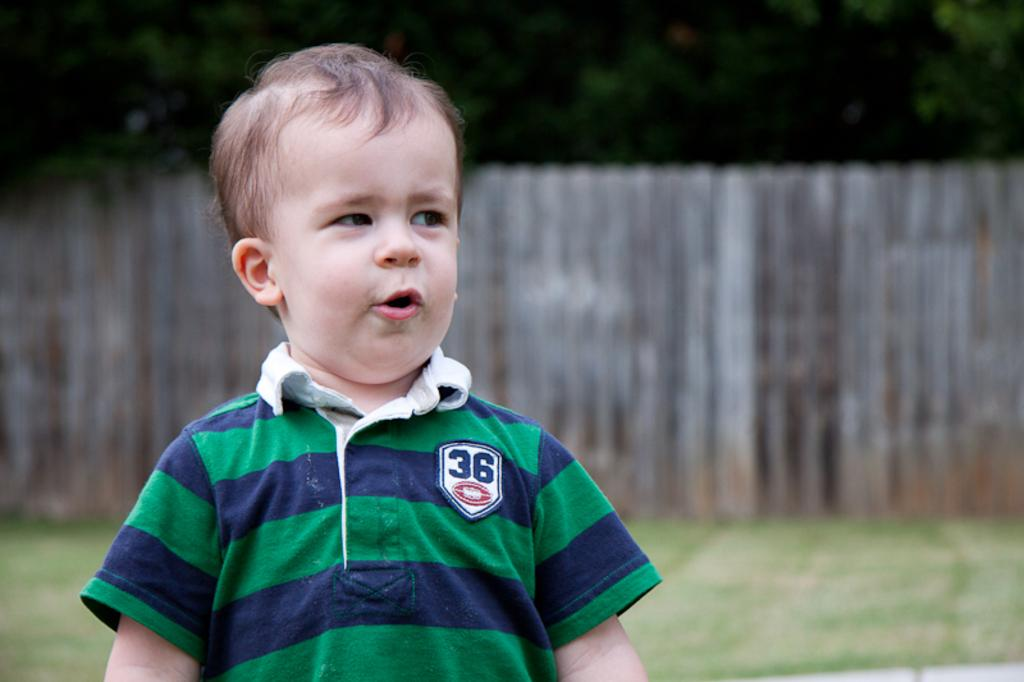<image>
Provide a brief description of the given image. A toddler wearing a green and blue polo with the number 36 patch on the right side. 